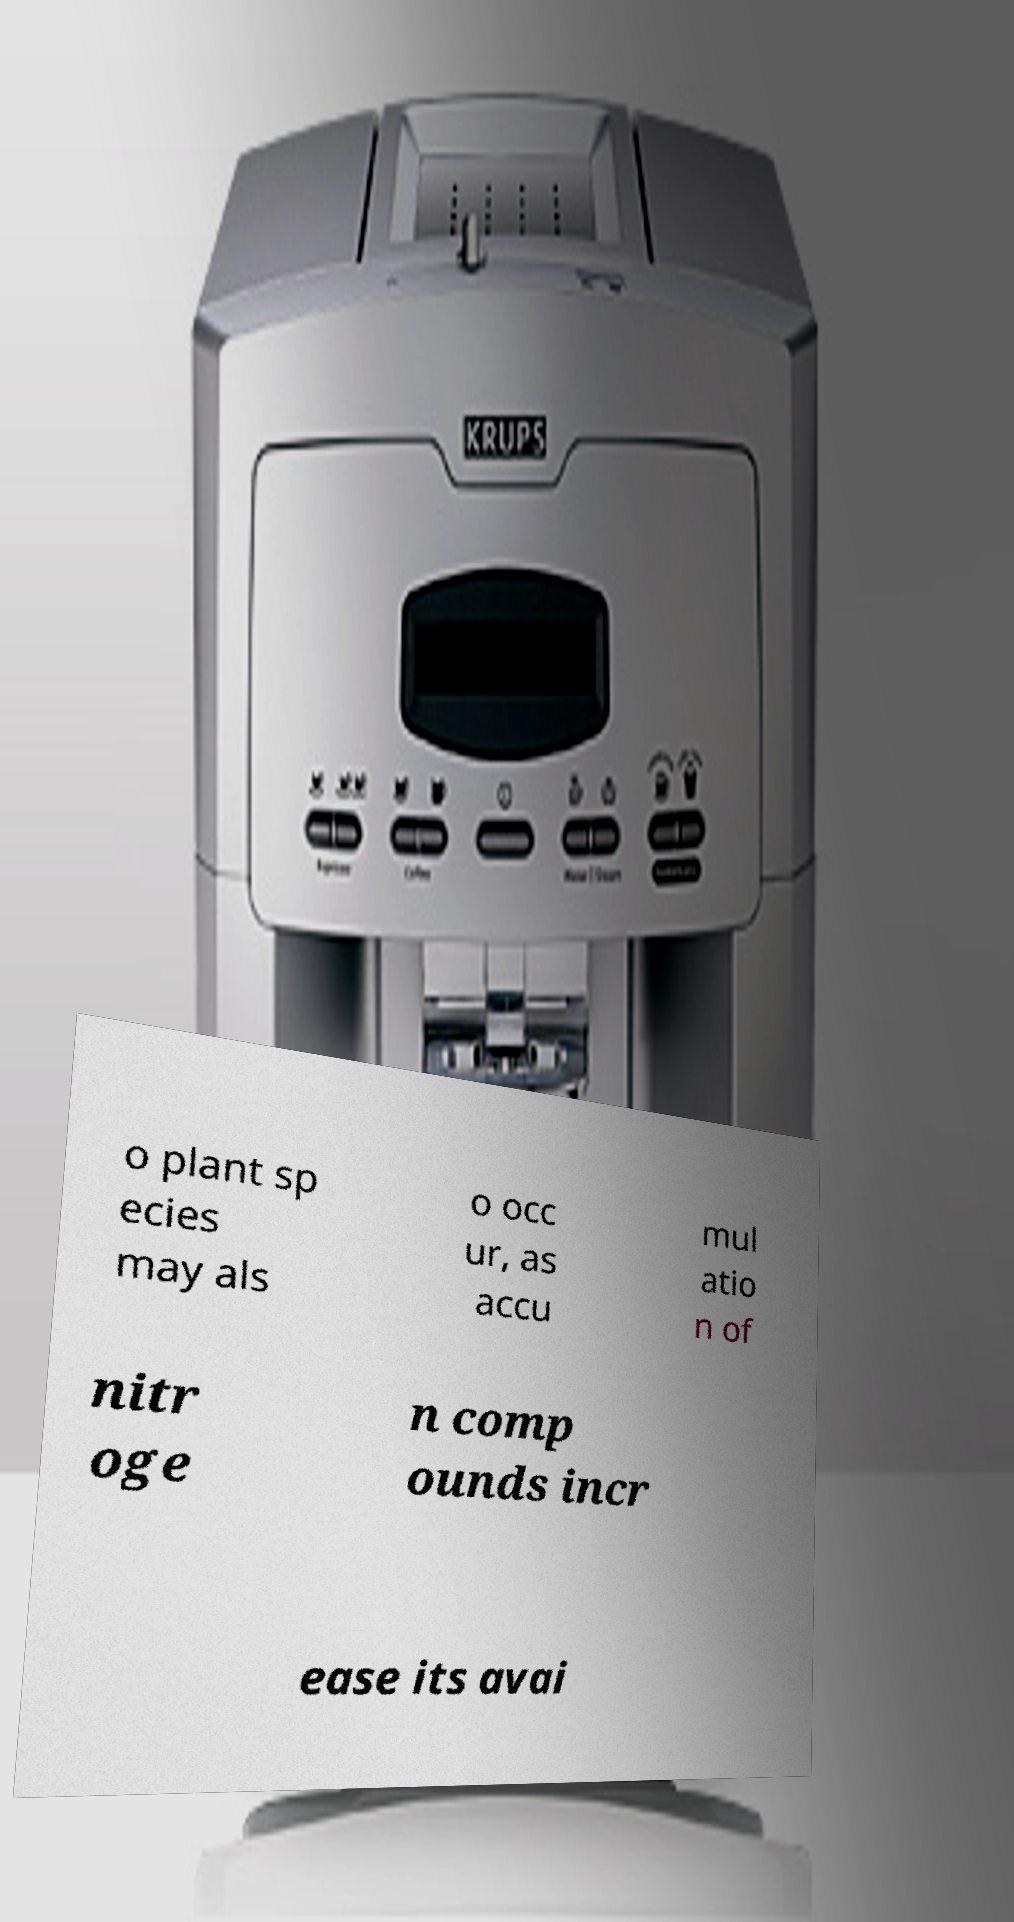For documentation purposes, I need the text within this image transcribed. Could you provide that? o plant sp ecies may als o occ ur, as accu mul atio n of nitr oge n comp ounds incr ease its avai 